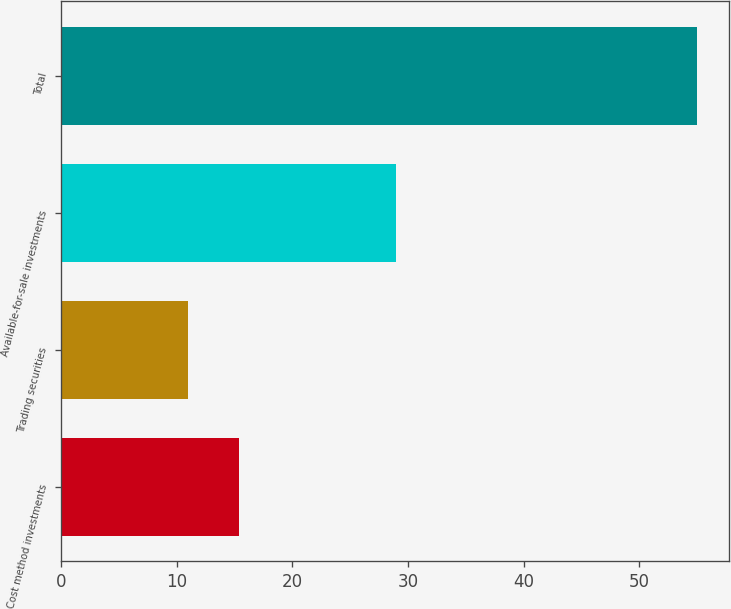Convert chart. <chart><loc_0><loc_0><loc_500><loc_500><bar_chart><fcel>Cost method investments<fcel>Trading securities<fcel>Available-for-sale investments<fcel>Total<nl><fcel>15.4<fcel>11<fcel>29<fcel>55<nl></chart> 